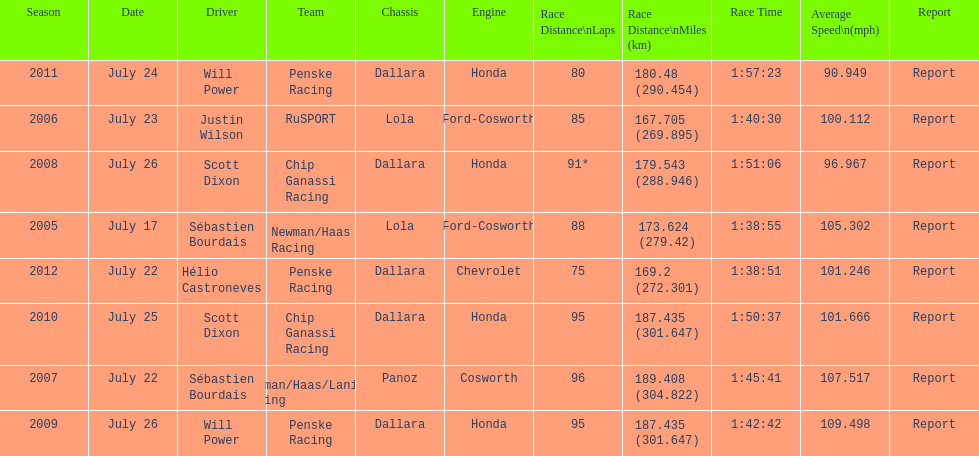How many times did sébastien bourdais win the champ car world series between 2005 and 2007? 2. 